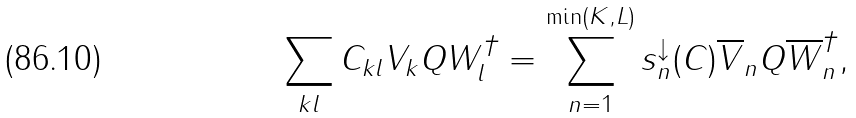<formula> <loc_0><loc_0><loc_500><loc_500>\sum _ { k l } C _ { k l } V _ { k } Q W _ { l } ^ { \dagger } = \sum _ { n = 1 } ^ { \min ( K , L ) } s _ { n } ^ { \downarrow } ( C ) \overline { V } _ { n } Q \overline { W } _ { n } ^ { \dagger } ,</formula> 